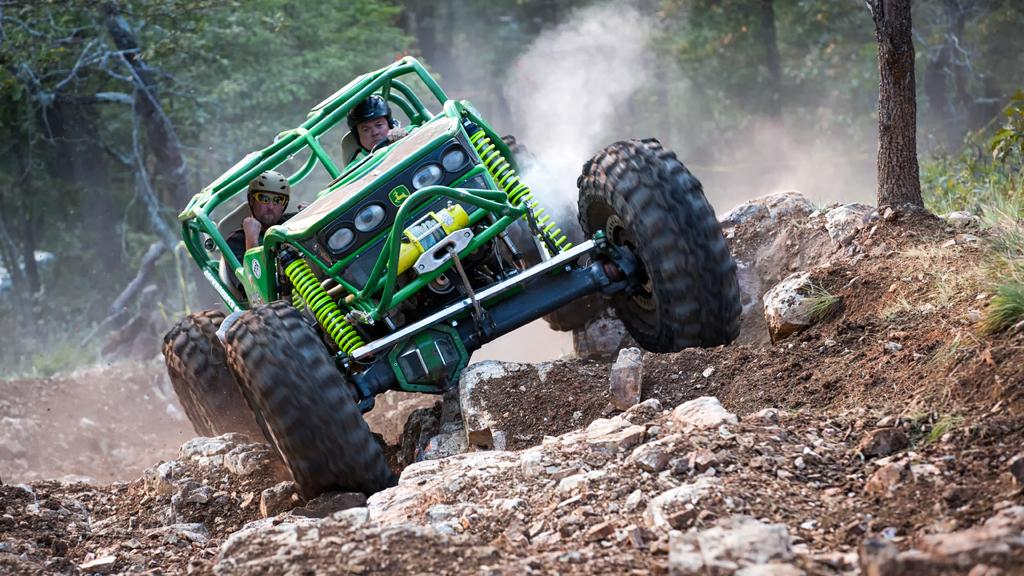How many people are in the image? There are two people in the image. What are the two people doing in the image? The two people are traveling in a vehicle. What is the condition of the surface the vehicle is moving on? The vehicle is moving on a rough surface. What can be seen in the surroundings of the vehicle? There are many trees around the vehicle. Can you see the ocean in the image? No, the ocean is not visible in the image. The image shows two people traveling in a vehicle on a rough surface surrounded by trees. 